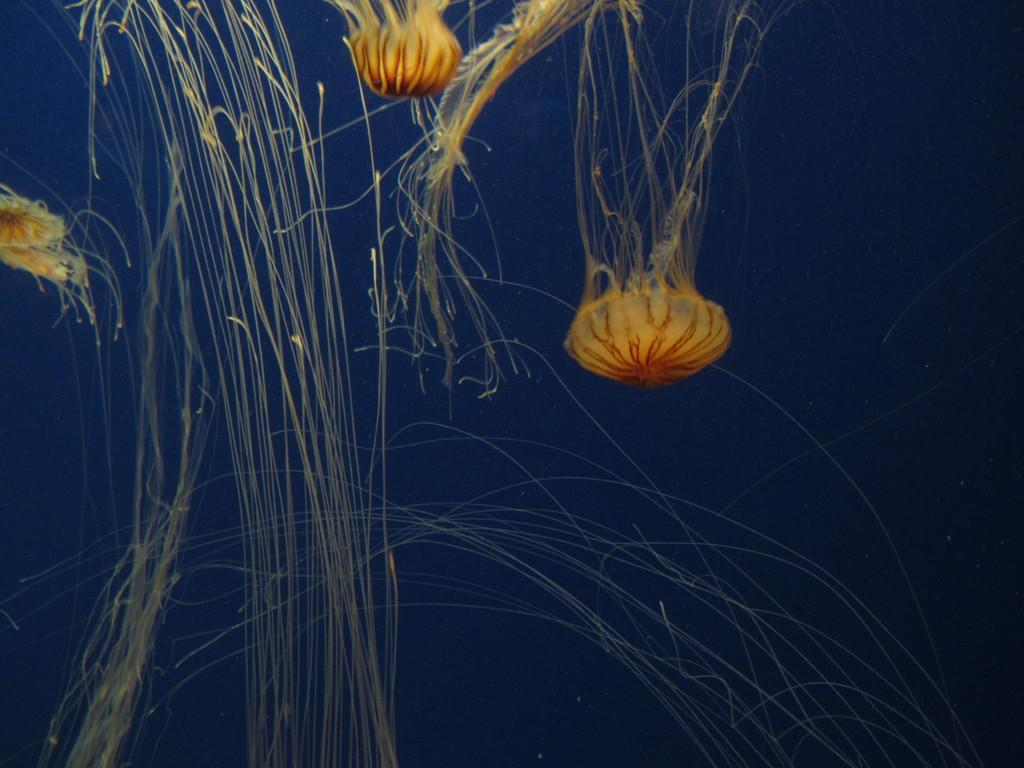What type of animals can be seen in the water in the image? There are jellyfishes in the water. Can you describe the environment in which the jellyfishes are located? The jellyfishes are located in water. How many basketballs can be seen hanging from the cobweb in the image? There are no basketballs or cobwebs present in the image; it features jellyfishes in water. 